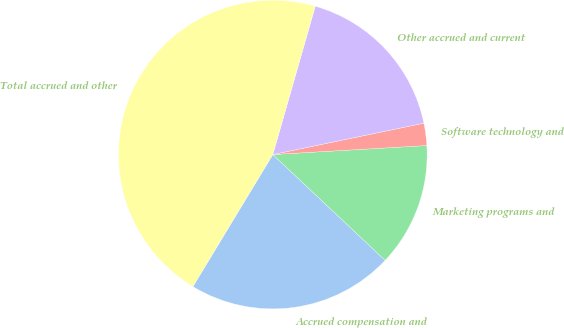Convert chart to OTSL. <chart><loc_0><loc_0><loc_500><loc_500><pie_chart><fcel>Accrued compensation and<fcel>Marketing programs and<fcel>Software technology and<fcel>Other accrued and current<fcel>Total accrued and other<nl><fcel>21.64%<fcel>12.95%<fcel>2.33%<fcel>17.3%<fcel>45.77%<nl></chart> 